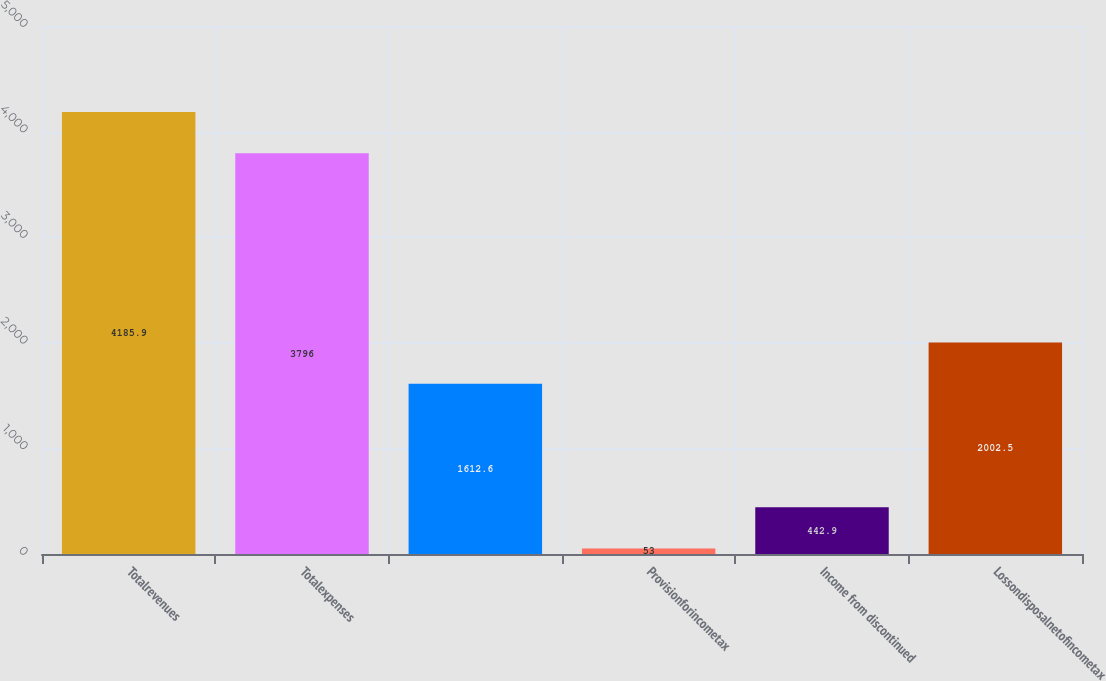Convert chart to OTSL. <chart><loc_0><loc_0><loc_500><loc_500><bar_chart><fcel>Totalrevenues<fcel>Totalexpenses<fcel>Unnamed: 2<fcel>Provisionforincometax<fcel>Income from discontinued<fcel>Lossondisposalnetofincometax<nl><fcel>4185.9<fcel>3796<fcel>1612.6<fcel>53<fcel>442.9<fcel>2002.5<nl></chart> 